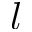<formula> <loc_0><loc_0><loc_500><loc_500>l</formula> 